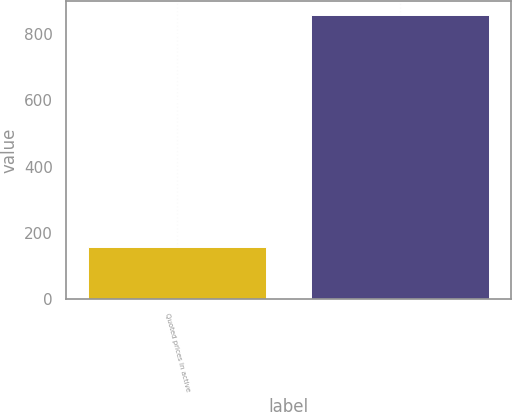Convert chart. <chart><loc_0><loc_0><loc_500><loc_500><bar_chart><fcel>Quoted prices in active<fcel>Unnamed: 1<nl><fcel>156<fcel>858<nl></chart> 